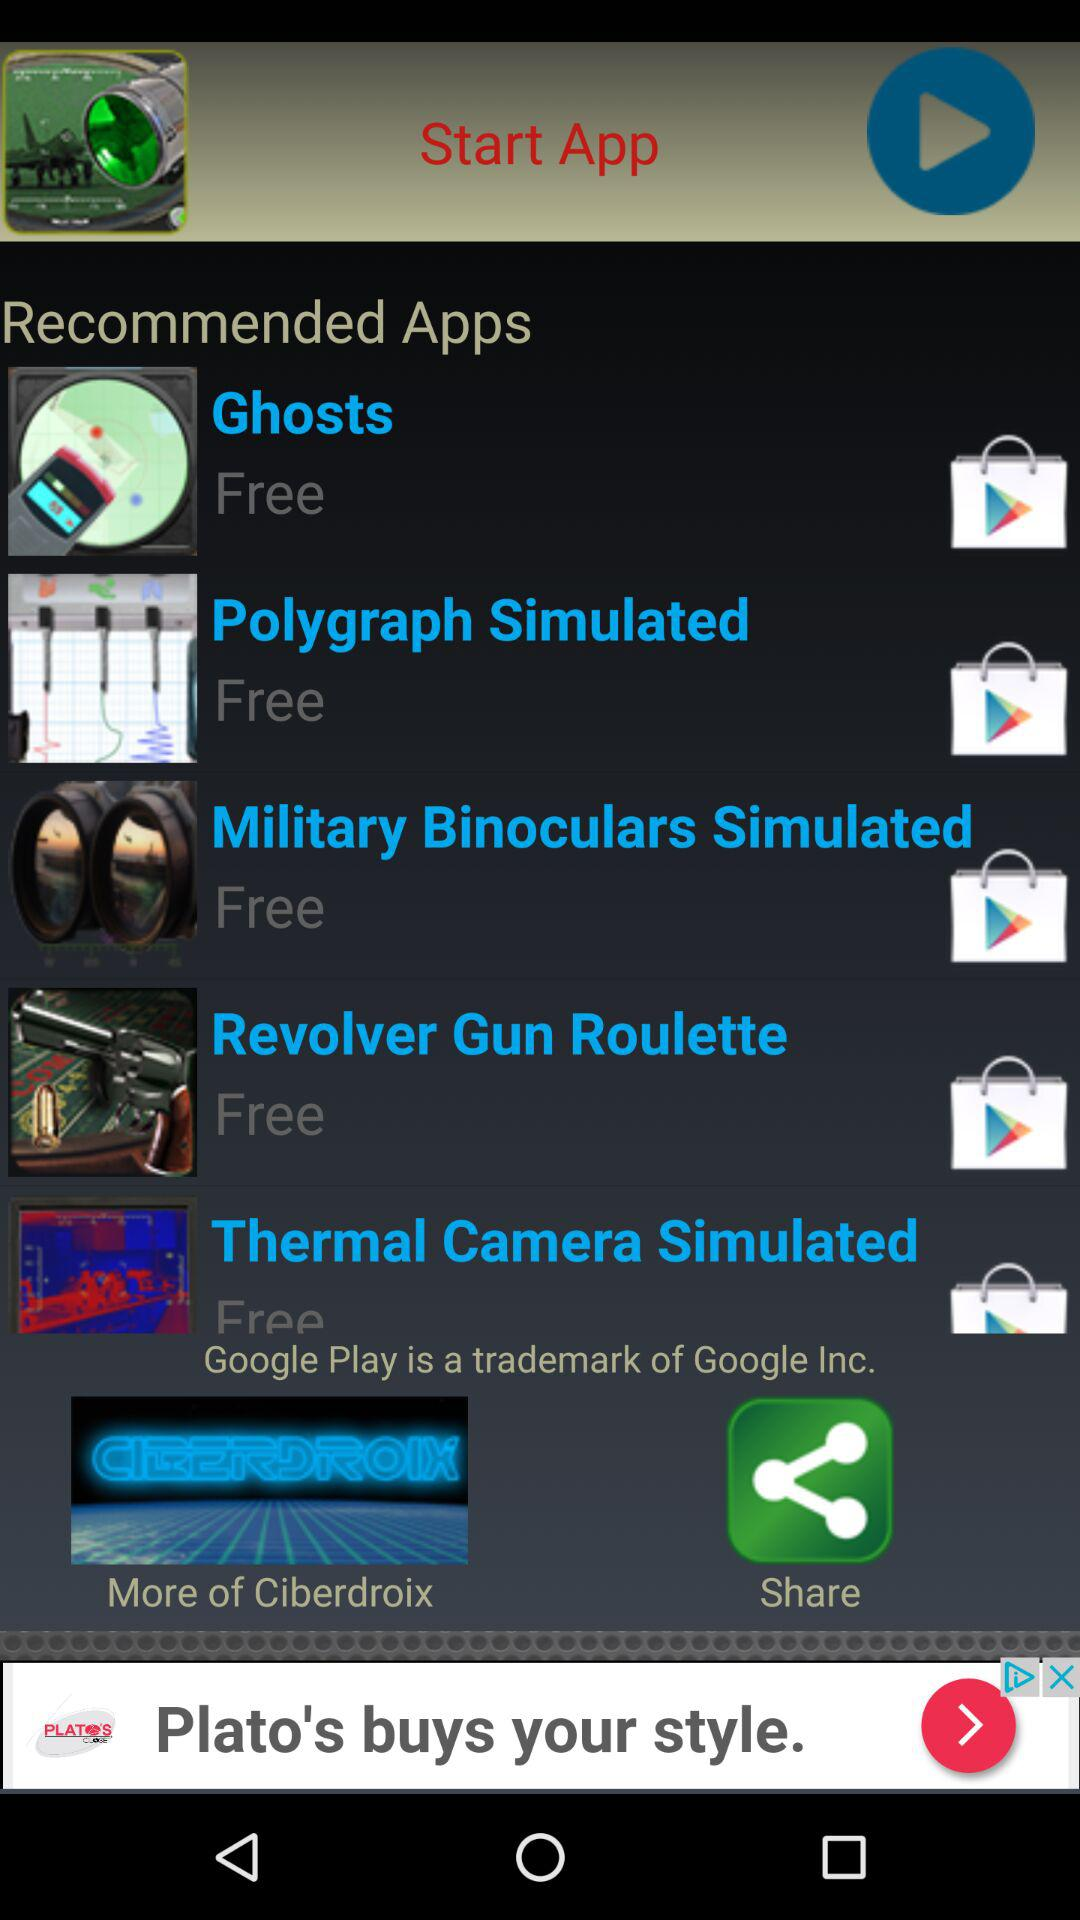What is the price of "Revolver Gun Roulette"? "Revolver Gun Roulette" is free. 